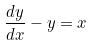Convert formula to latex. <formula><loc_0><loc_0><loc_500><loc_500>\frac { d y } { d x } - y = x</formula> 